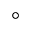<formula> <loc_0><loc_0><loc_500><loc_500>^ { \circ }</formula> 